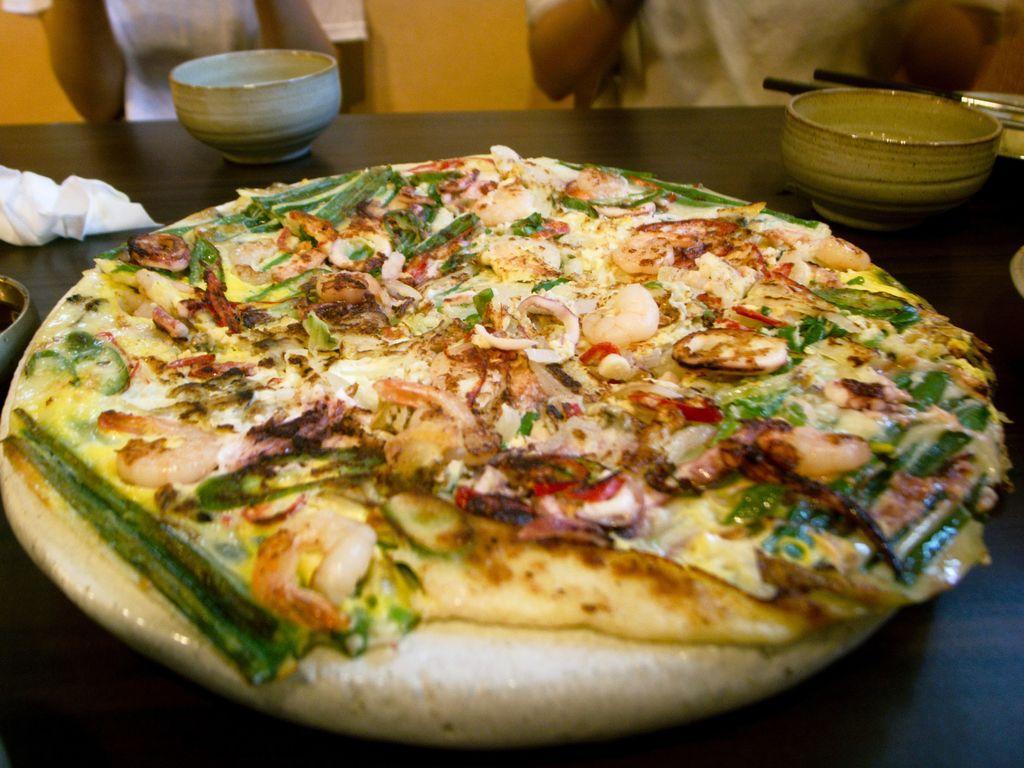Can you describe this image briefly? In this image we can see there is a food item, two bowls and some other objects placed on the table, in front of the table there are two persons. 